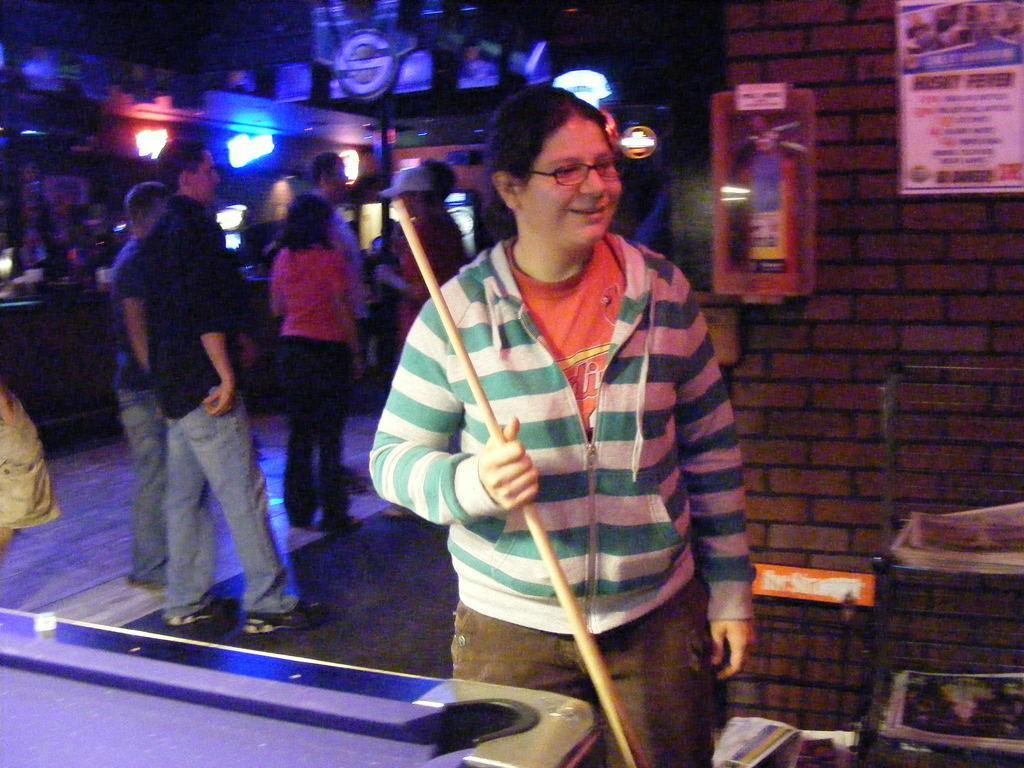Can you describe this image briefly? In this picture we can see a lady holding a stick in blue and white jacket and behind her are some people Standing and some lights and notes to the wall. 